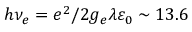<formula> <loc_0><loc_0><loc_500><loc_500>h \nu _ { e } = e ^ { 2 } / 2 g _ { e } \lambda \varepsilon _ { 0 } \sim 1 3 . 6</formula> 